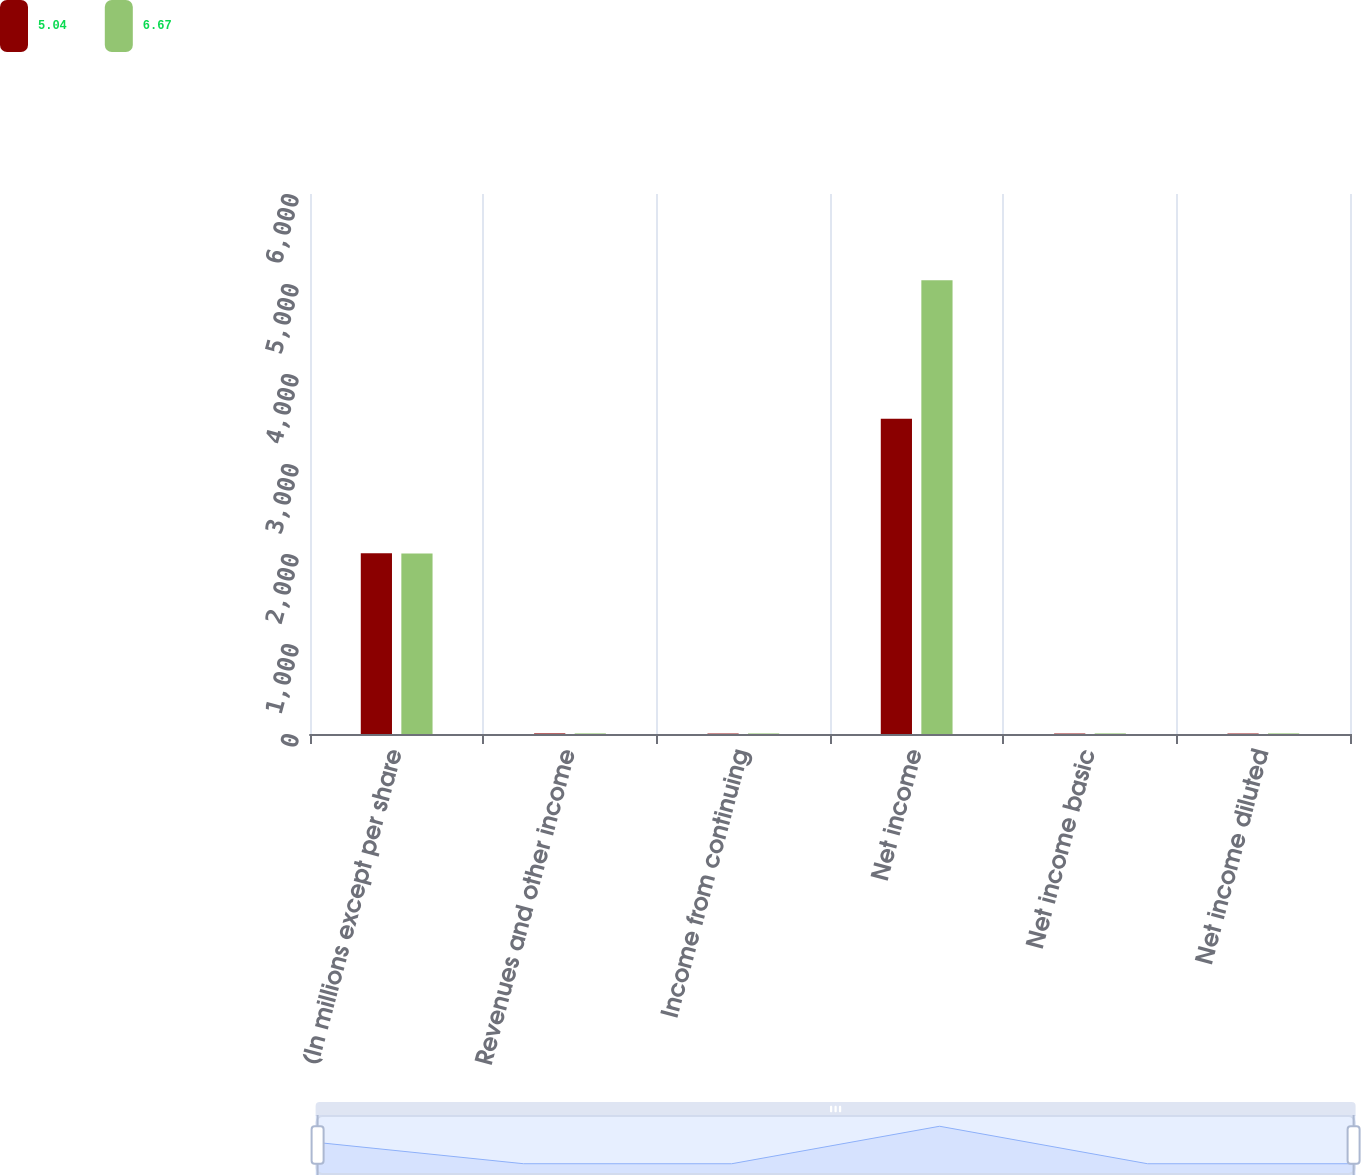<chart> <loc_0><loc_0><loc_500><loc_500><stacked_bar_chart><ecel><fcel>(In millions except per share<fcel>Revenues and other income<fcel>Income from continuing<fcel>Net income<fcel>Net income basic<fcel>Net income diluted<nl><fcel>5.04<fcel>2007<fcel>6.695<fcel>5.03<fcel>3503<fcel>5.08<fcel>5.04<nl><fcel>6.67<fcel>2006<fcel>6.695<fcel>6.3<fcel>5042<fcel>6.72<fcel>6.67<nl></chart> 